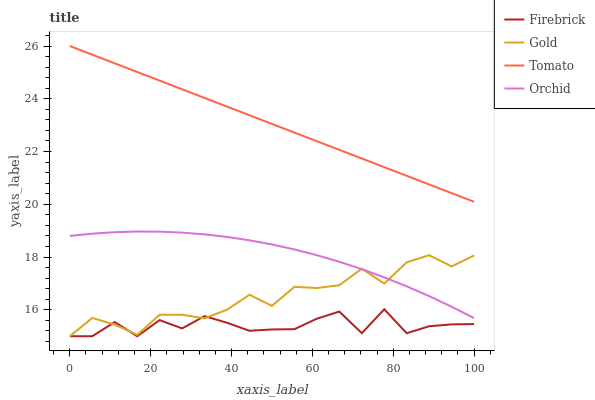Does Firebrick have the minimum area under the curve?
Answer yes or no. Yes. Does Tomato have the maximum area under the curve?
Answer yes or no. Yes. Does Gold have the minimum area under the curve?
Answer yes or no. No. Does Gold have the maximum area under the curve?
Answer yes or no. No. Is Tomato the smoothest?
Answer yes or no. Yes. Is Firebrick the roughest?
Answer yes or no. Yes. Is Gold the smoothest?
Answer yes or no. No. Is Gold the roughest?
Answer yes or no. No. Does Firebrick have the lowest value?
Answer yes or no. Yes. Does Orchid have the lowest value?
Answer yes or no. No. Does Tomato have the highest value?
Answer yes or no. Yes. Does Gold have the highest value?
Answer yes or no. No. Is Orchid less than Tomato?
Answer yes or no. Yes. Is Tomato greater than Firebrick?
Answer yes or no. Yes. Does Orchid intersect Gold?
Answer yes or no. Yes. Is Orchid less than Gold?
Answer yes or no. No. Is Orchid greater than Gold?
Answer yes or no. No. Does Orchid intersect Tomato?
Answer yes or no. No. 